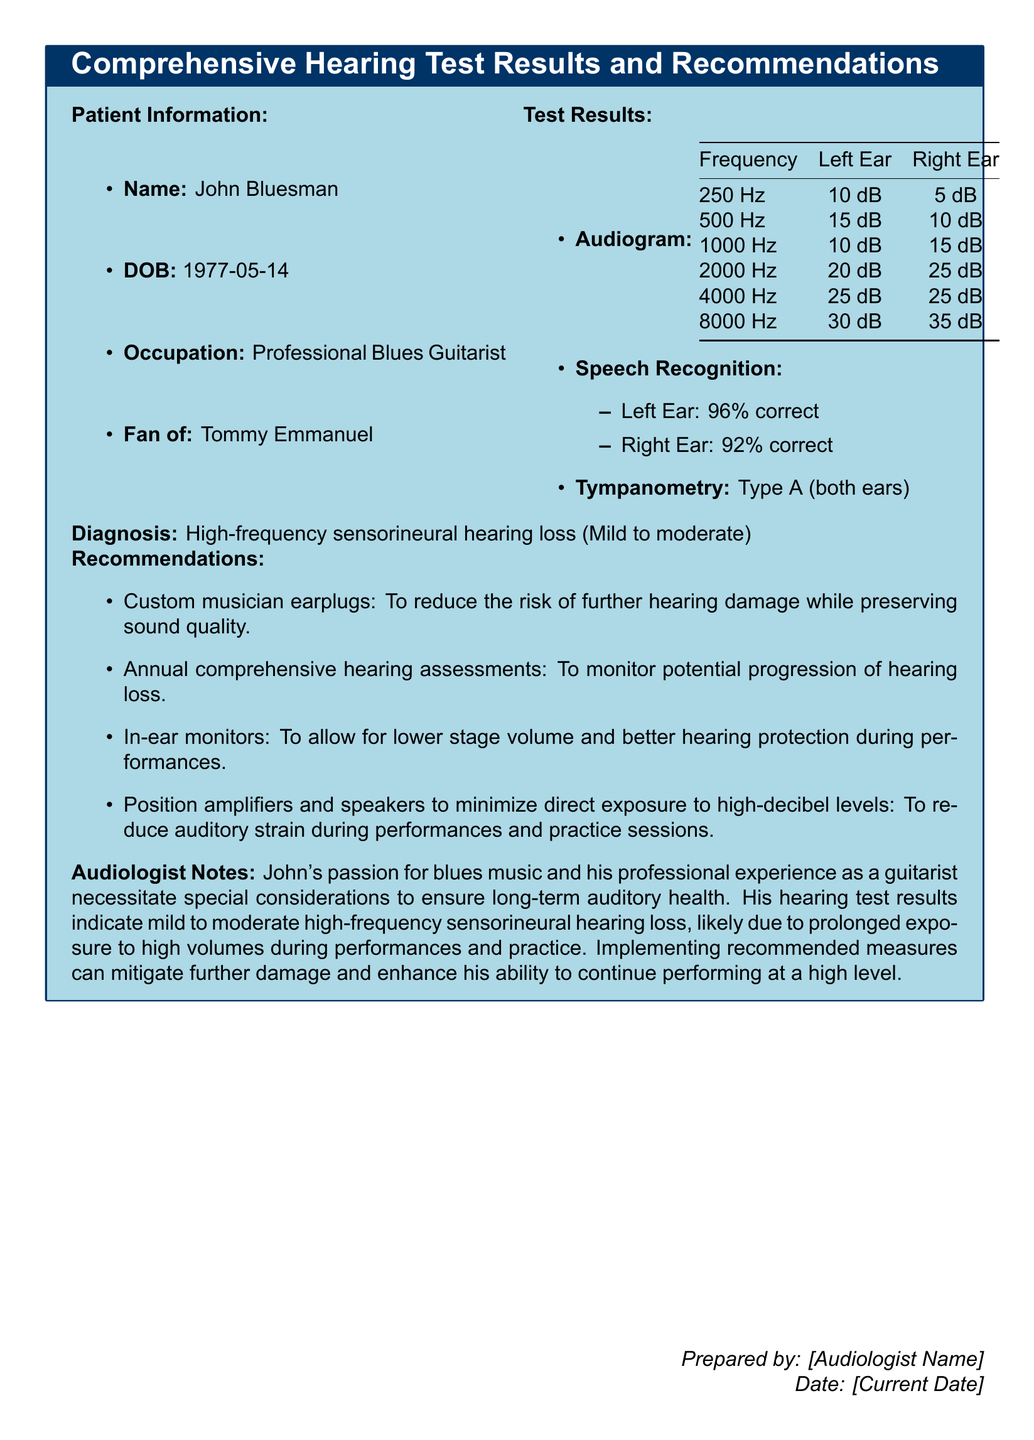What is the patient's name? The patient's name is mentioned in the patient information section of the document.
Answer: John Bluesman What is the date of birth? The date of birth is provided in the patient information section.
Answer: 1977-05-14 What is the diagnosis in the document? The diagnosis is stated clearly in the findings of the document.
Answer: High-frequency sensorineural hearing loss (Mild to moderate) What is the speech recognition percentage in the left ear? The speech recognition percentage is detailed in the test results section.
Answer: 96% What type of tympanometry result is noted for both ears? The tympanometry results are specified in the test results section of the document.
Answer: Type A (both ears) What is one recommended measure for the patient? Recommendations are listed in the document, and one is highlighted.
Answer: Custom musician earplugs How often should the patient have comprehensive hearing assessments? The frequency of hearing assessments is outlined in the recommendations section.
Answer: Annual What percentage of speech recognition was observed in the right ear? The percentage in the right ear is mentioned in the speech recognition test results.
Answer: 92% Why is the patient at risk for hearing damage? The reasoning is derived from the audiologist notes discussing potential causes of the hearing loss.
Answer: Prolonged exposure to high volumes during performances and practice 